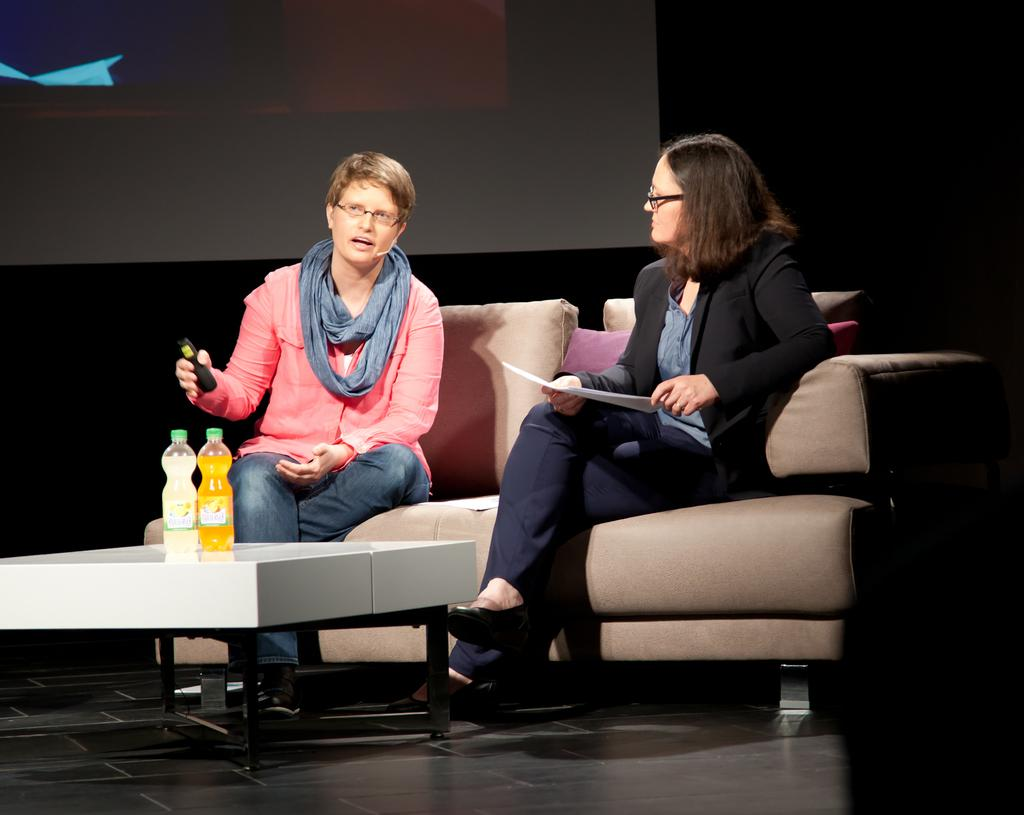How many people are in the image? There are two women in the image. What are the women doing in the image? The women are sitting on a sofa. What other piece of furniture is present in the image? There is a table in the image. What is on the table? There is a cool drink on the table. What type of haircut does the square have in the image? There is no square or haircut present in the image. What sound can be heard coming from the cool drink in the image? There is no sound coming from the cool drink in the image. 